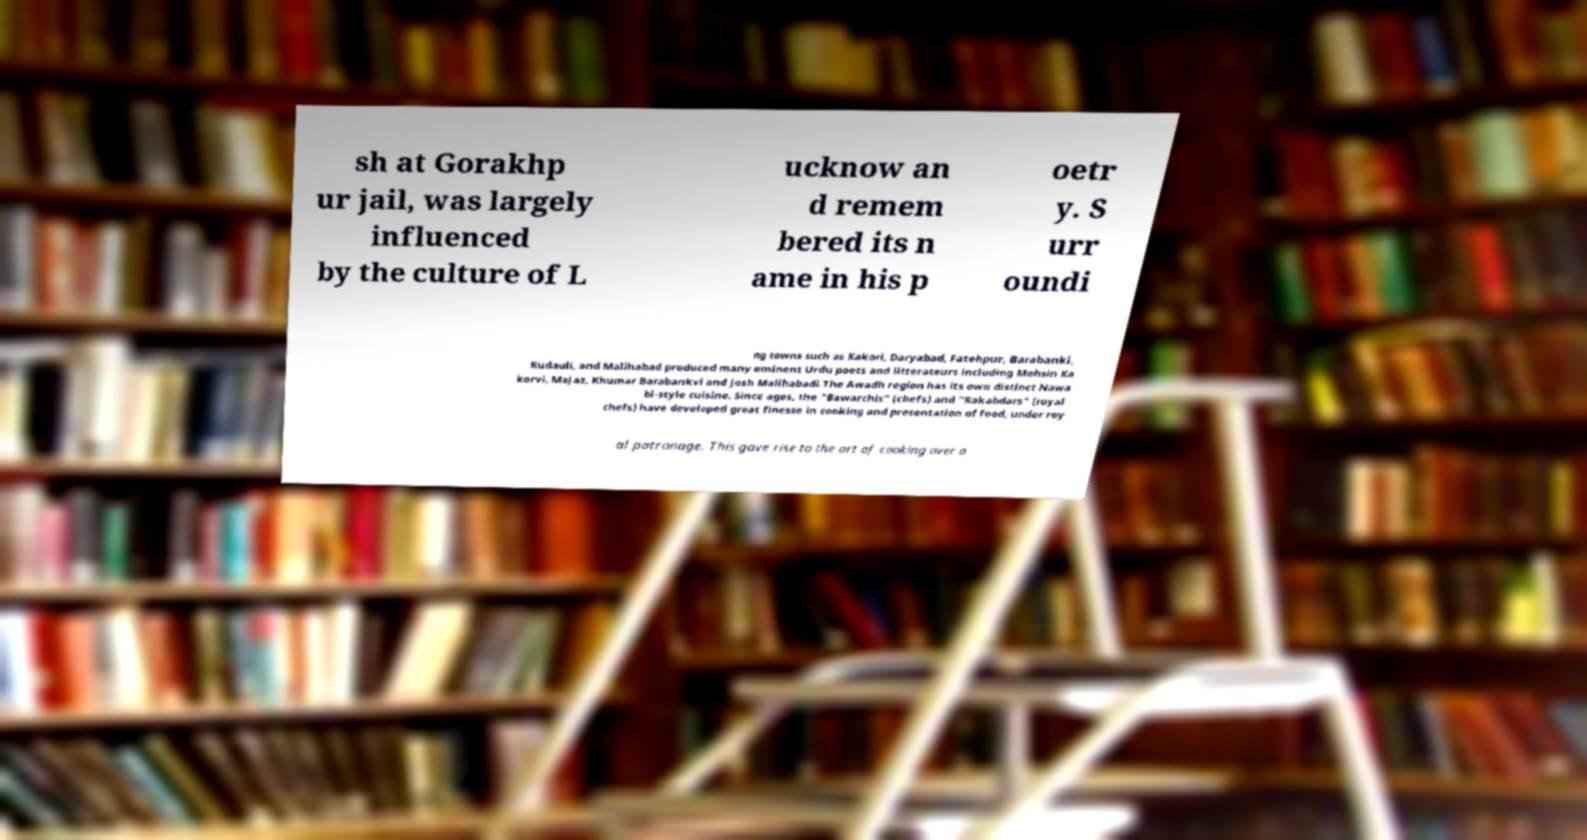Could you extract and type out the text from this image? sh at Gorakhp ur jail, was largely influenced by the culture of L ucknow an d remem bered its n ame in his p oetr y. S urr oundi ng towns such as Kakori, Daryabad, Fatehpur, Barabanki, Rudauli, and Malihabad produced many eminent Urdu poets and litterateurs including Mohsin Ka korvi, Majaz, Khumar Barabankvi and Josh Malihabadi.The Awadh region has its own distinct Nawa bi-style cuisine. Since ages, the "Bawarchis" (chefs) and "Rakabdars" (royal chefs) have developed great finesse in cooking and presentation of food, under roy al patronage. This gave rise to the art of cooking over a 